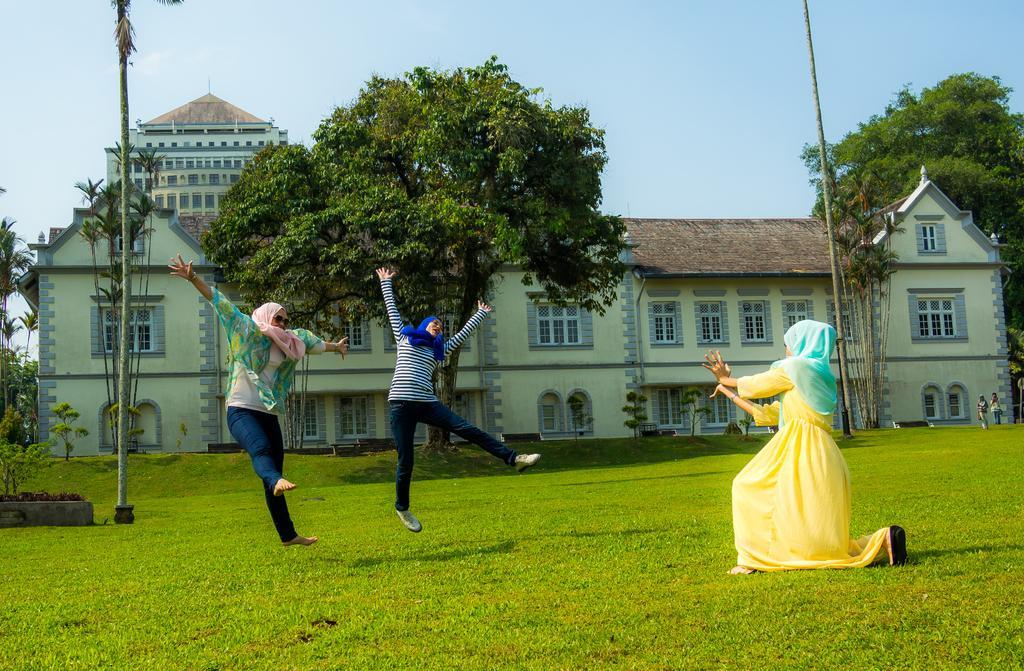Can you describe this image briefly? In this image we can see three ladies. They are wearing scarves. On the ground there is grass. In the back there is a building with windows. Also there are trees. And there is sky. 